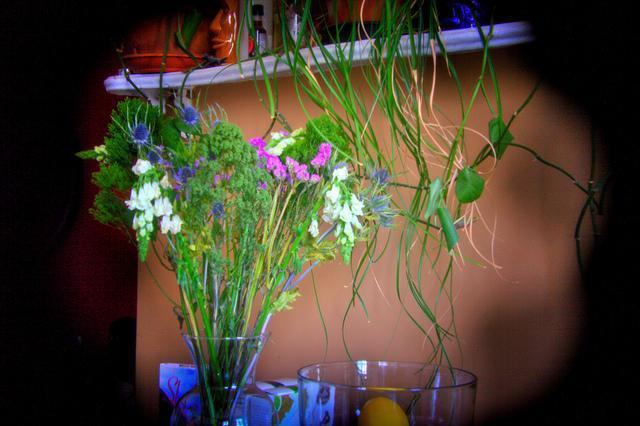How many vases are in the photo?
Give a very brief answer. 2. 